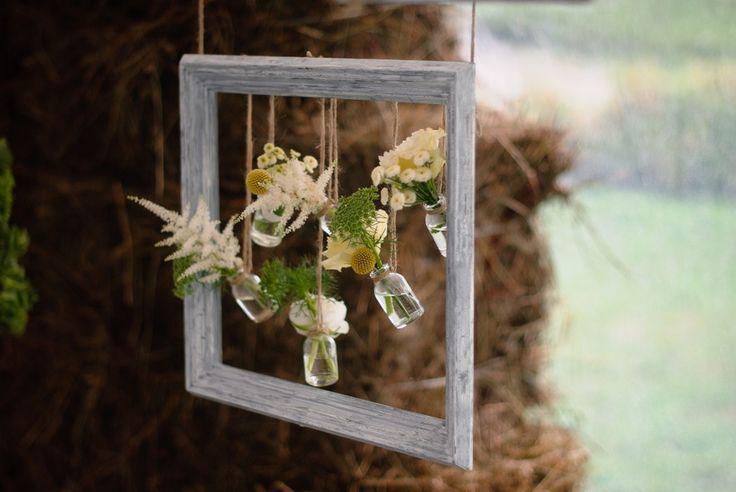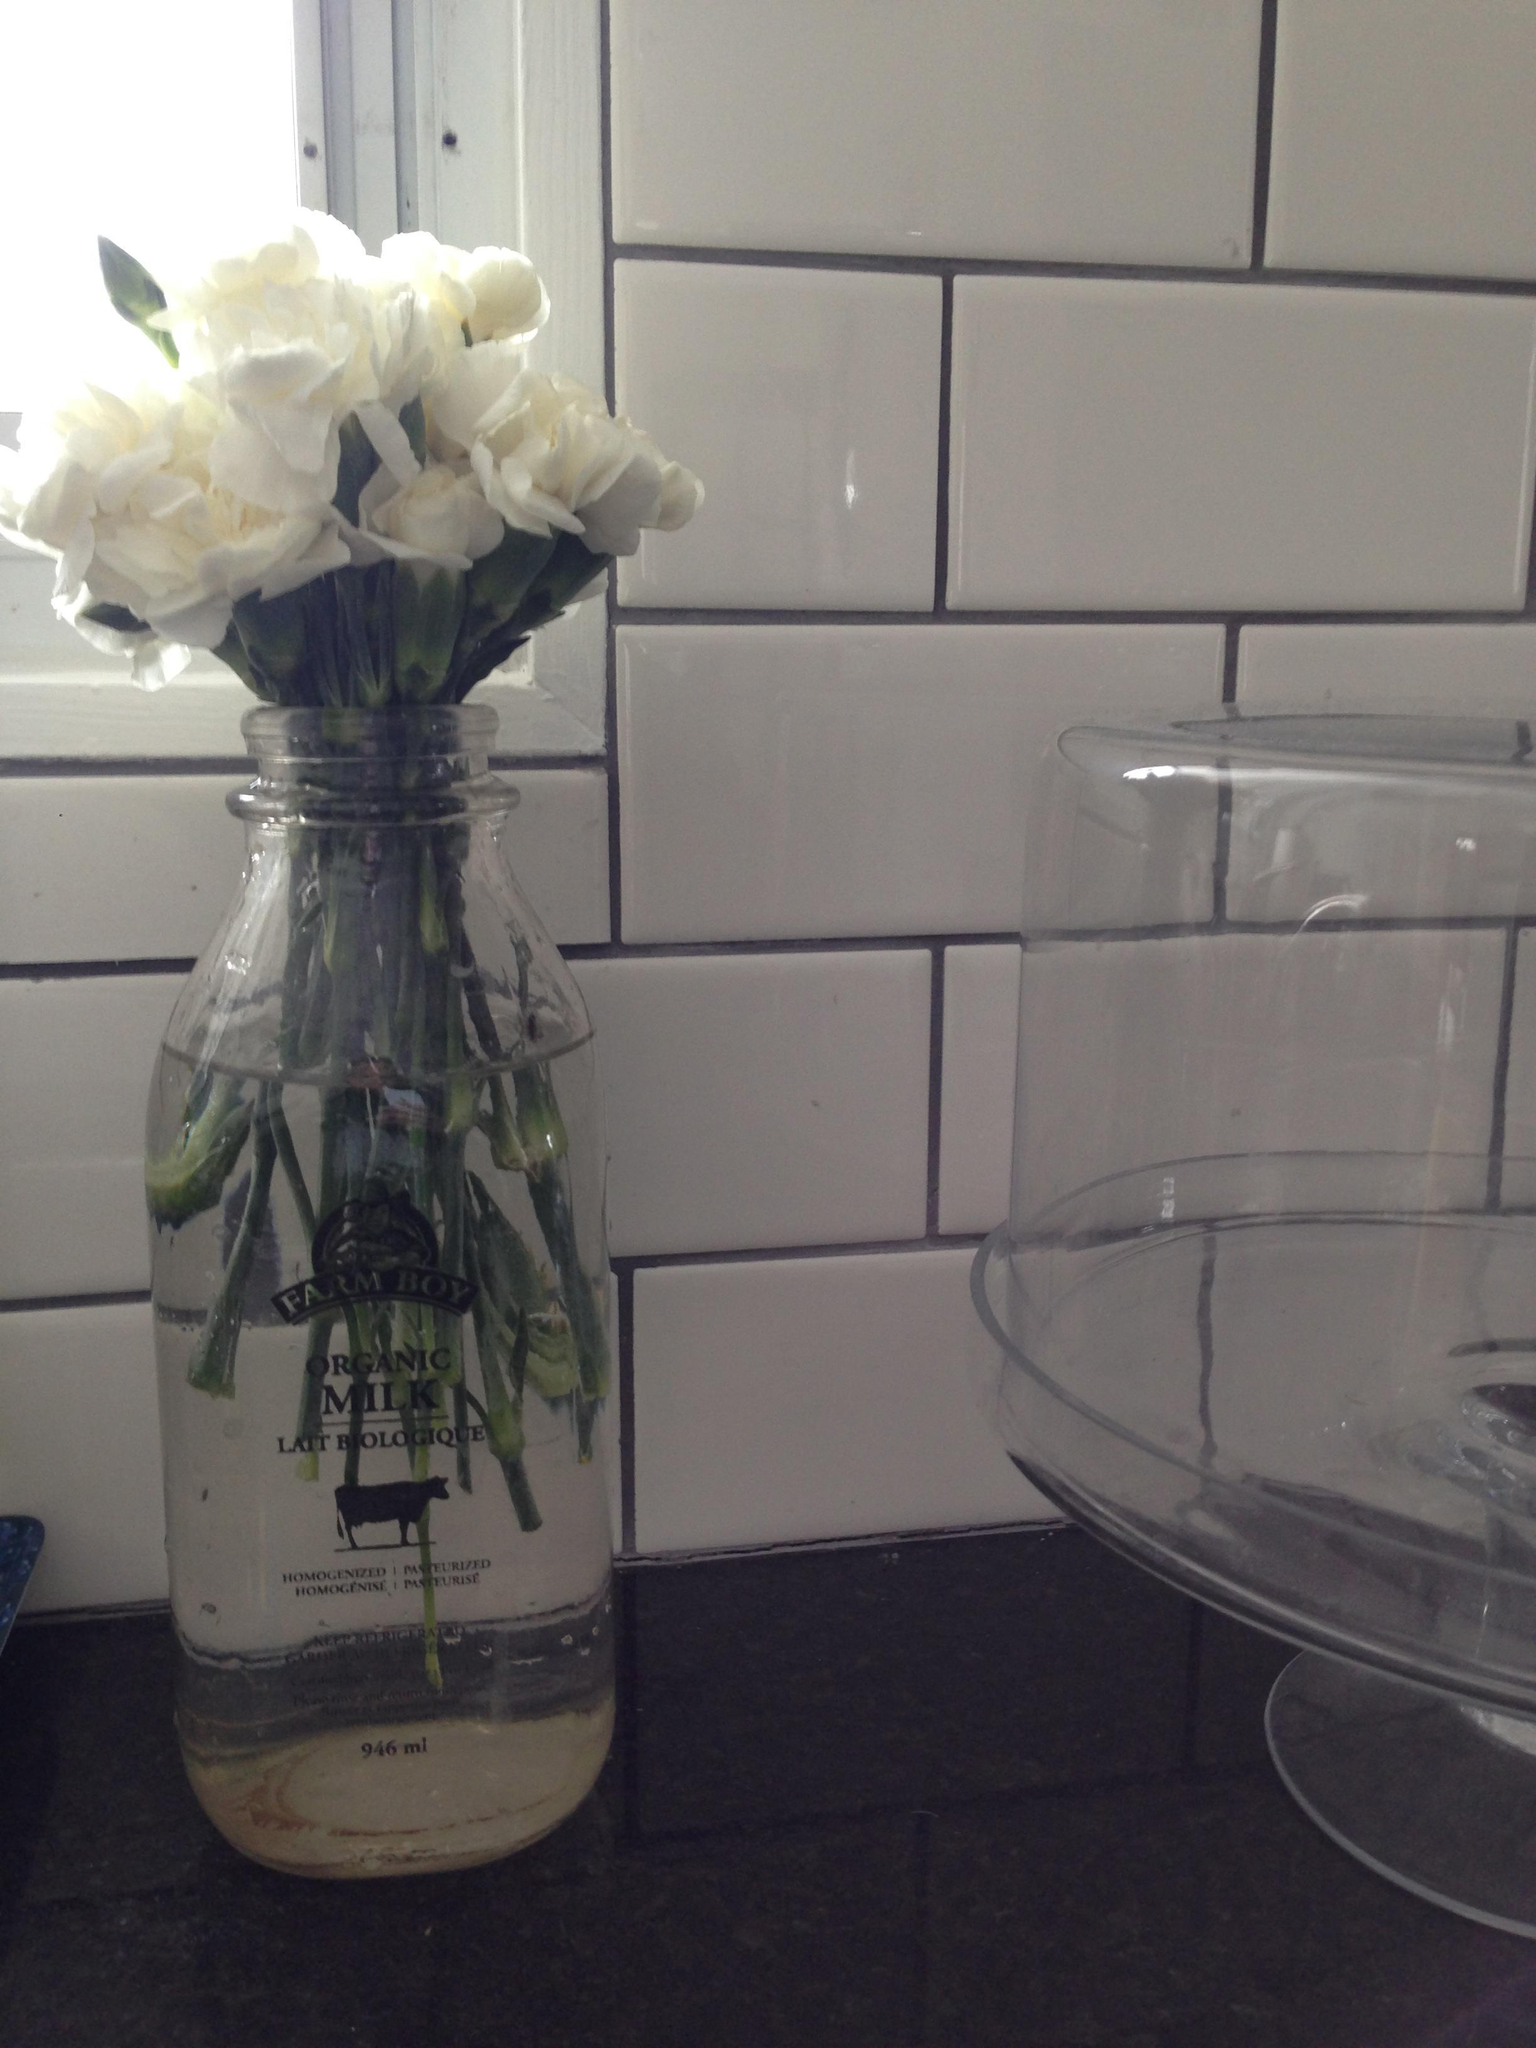The first image is the image on the left, the second image is the image on the right. Evaluate the accuracy of this statement regarding the images: "Floral arrangements are in all vases.". Is it true? Answer yes or no. Yes. 